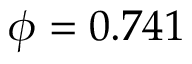Convert formula to latex. <formula><loc_0><loc_0><loc_500><loc_500>\phi = 0 . 7 4 1</formula> 